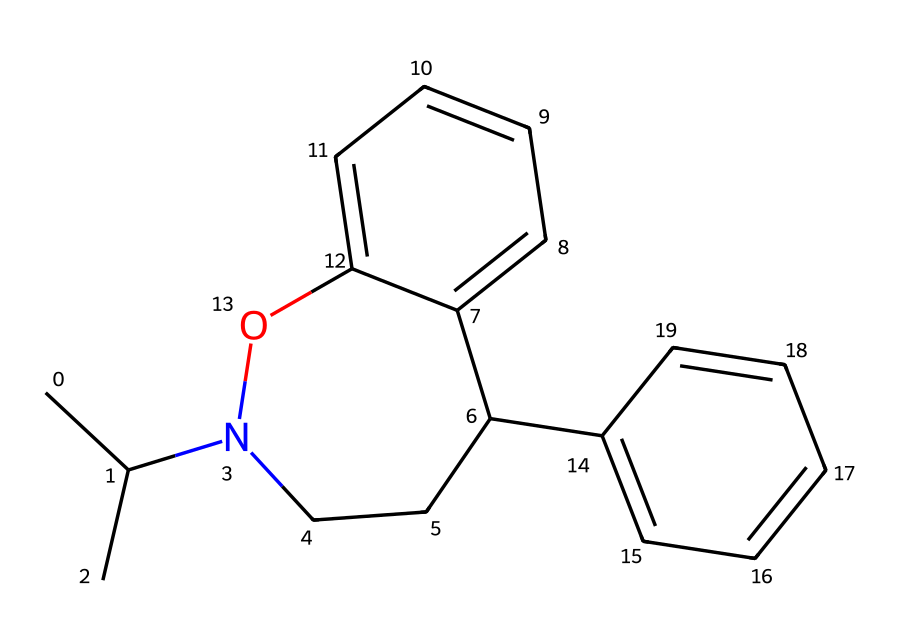What is the molecular formula of this chemical? To determine the molecular formula, count all the carbon (C), hydrogen (H), and nitrogen (N) atoms in the structure represented by the SMILES. The structure contains 17 carbon atoms, 23 hydrogen atoms, and 1 nitrogen atom. Thus, the molecular formula is C17H23N.
Answer: C17H23N How many rings are present in the structure? By analyzing the SMILES representation, we can identify the '1' markers, which indicate ring closures. The structure has two distinct rings (one cycloalkyl and one aromatic) as identified from the numbering in SMILES.
Answer: 2 What type of drug is represented by this chemical structure? This chemical structure is characteristic of a synthetic opioid due to the presence of the nitrogen atom (common in opioids) and its overall molecular framework that mimics natural opioid peptides.
Answer: synthetic opioid Does this chemical contain an aromatic ring? Yes, upon examining the structure, we see a benzene ring (aromatic) indicated by the 'c' notations in the SMILES, confirming the presence of an aromatic system.
Answer: yes What functional group is primarily responsible for the action of this drug? The presence of the nitrogen atom contributes to its classification as an amine, which is crucial for the interaction with opioid receptors in the brain, thus playing a significant role in its action.
Answer: amine Calculate the total number of atoms in the chemical structure. By summing the individual atoms found in the structure: 17 carbon atoms + 23 hydrogen atoms + 1 nitrogen atom + 1 oxygen atom yields a total of 42 atoms.
Answer: 42 